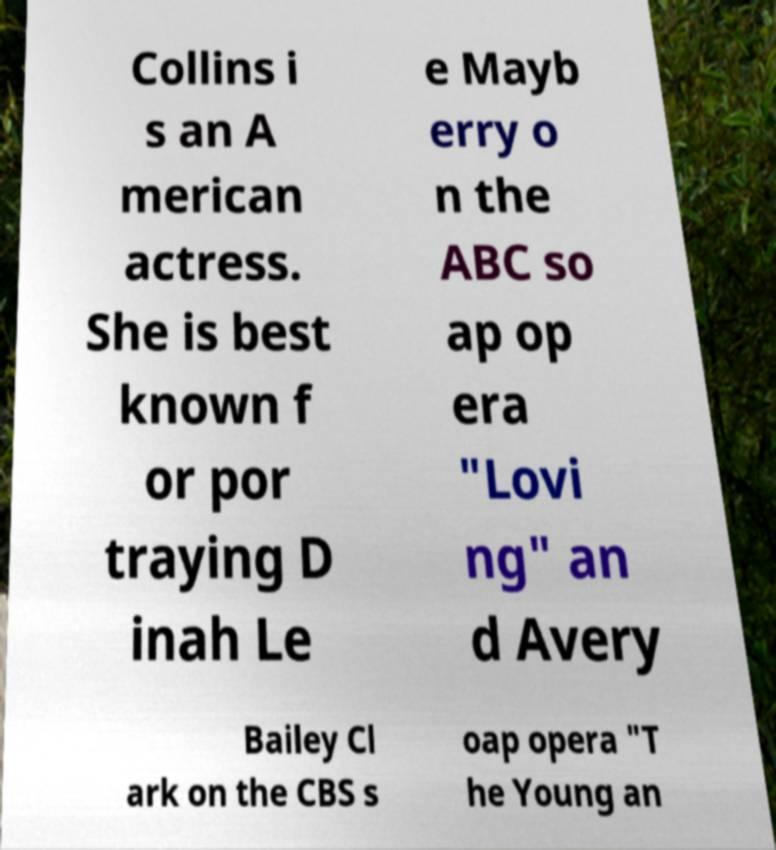I need the written content from this picture converted into text. Can you do that? Collins i s an A merican actress. She is best known f or por traying D inah Le e Mayb erry o n the ABC so ap op era "Lovi ng" an d Avery Bailey Cl ark on the CBS s oap opera "T he Young an 